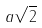<formula> <loc_0><loc_0><loc_500><loc_500>a \sqrt { 2 }</formula> 